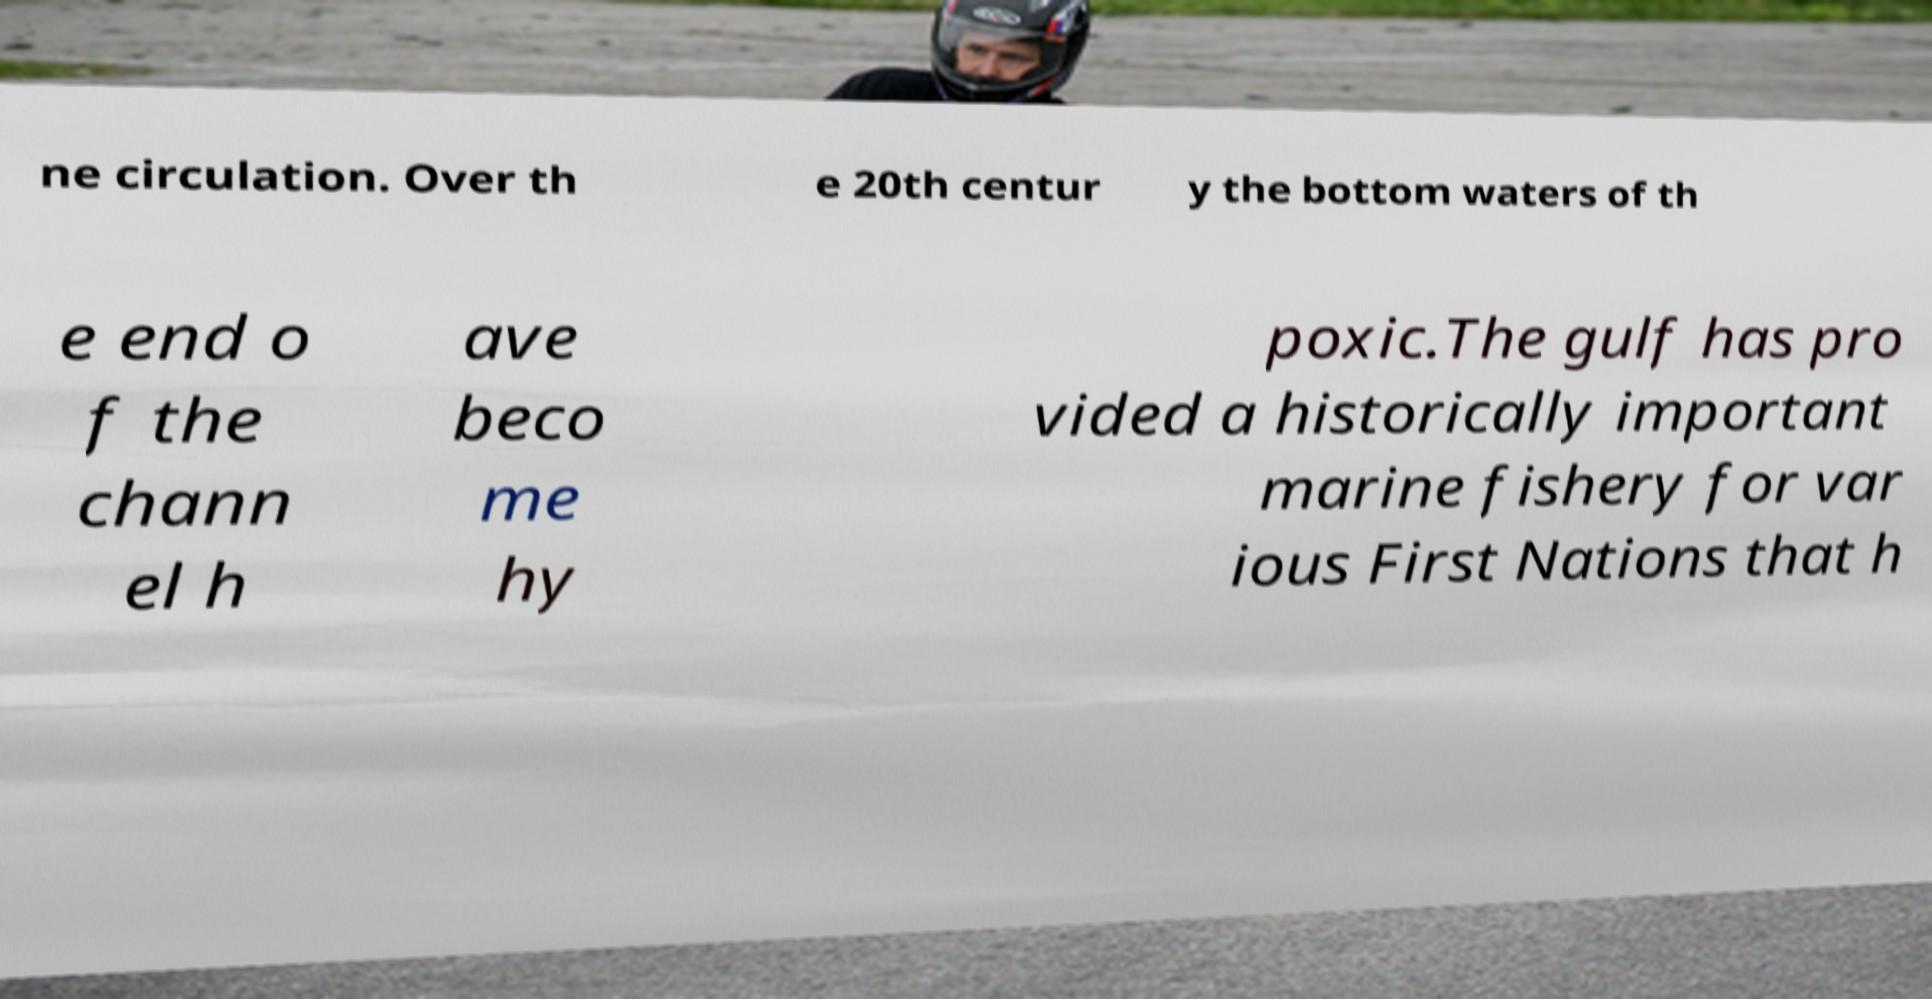Could you assist in decoding the text presented in this image and type it out clearly? ne circulation. Over th e 20th centur y the bottom waters of th e end o f the chann el h ave beco me hy poxic.The gulf has pro vided a historically important marine fishery for var ious First Nations that h 